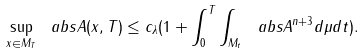Convert formula to latex. <formula><loc_0><loc_0><loc_500><loc_500>\sup _ { x \in M _ { T } } \ a b s { A ( x , T ) } \leq c _ { \lambda } ( 1 + \int _ { 0 } ^ { T } \int _ { M _ { t } } \ a b s { A } ^ { n + 3 } d \mu d t ) .</formula> 